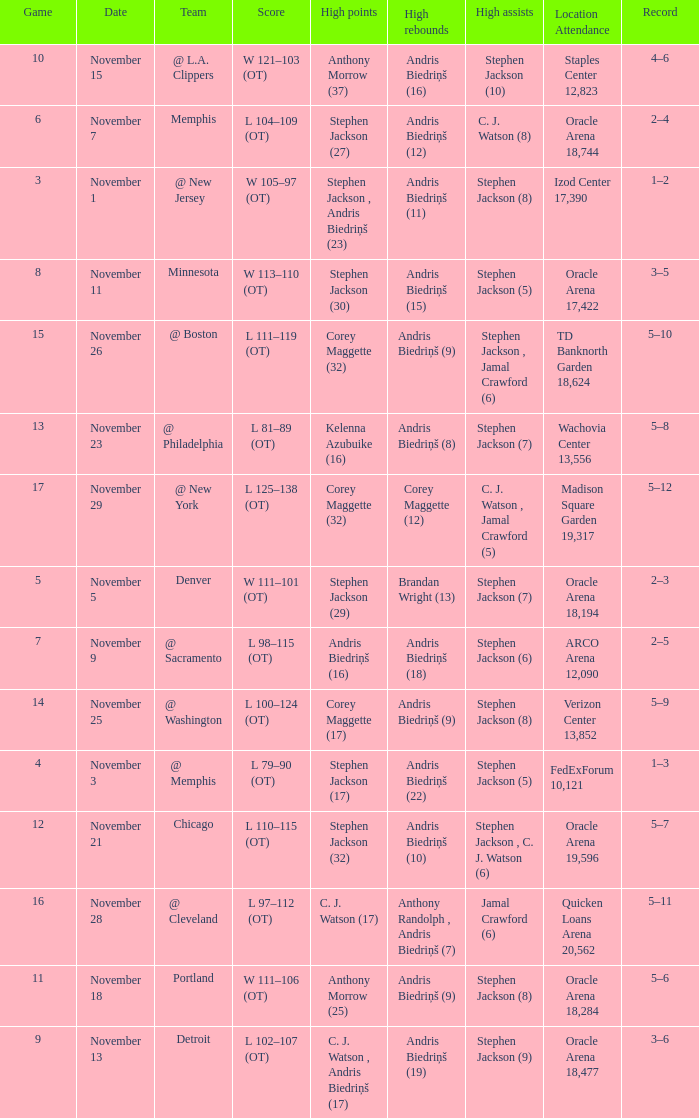What was the game number that was played on November 15? 10.0. Parse the full table. {'header': ['Game', 'Date', 'Team', 'Score', 'High points', 'High rebounds', 'High assists', 'Location Attendance', 'Record'], 'rows': [['10', 'November 15', '@ L.A. Clippers', 'W 121–103 (OT)', 'Anthony Morrow (37)', 'Andris Biedriņš (16)', 'Stephen Jackson (10)', 'Staples Center 12,823', '4–6'], ['6', 'November 7', 'Memphis', 'L 104–109 (OT)', 'Stephen Jackson (27)', 'Andris Biedriņš (12)', 'C. J. Watson (8)', 'Oracle Arena 18,744', '2–4'], ['3', 'November 1', '@ New Jersey', 'W 105–97 (OT)', 'Stephen Jackson , Andris Biedriņš (23)', 'Andris Biedriņš (11)', 'Stephen Jackson (8)', 'Izod Center 17,390', '1–2'], ['8', 'November 11', 'Minnesota', 'W 113–110 (OT)', 'Stephen Jackson (30)', 'Andris Biedriņš (15)', 'Stephen Jackson (5)', 'Oracle Arena 17,422', '3–5'], ['15', 'November 26', '@ Boston', 'L 111–119 (OT)', 'Corey Maggette (32)', 'Andris Biedriņš (9)', 'Stephen Jackson , Jamal Crawford (6)', 'TD Banknorth Garden 18,624', '5–10'], ['13', 'November 23', '@ Philadelphia', 'L 81–89 (OT)', 'Kelenna Azubuike (16)', 'Andris Biedriņš (8)', 'Stephen Jackson (7)', 'Wachovia Center 13,556', '5–8'], ['17', 'November 29', '@ New York', 'L 125–138 (OT)', 'Corey Maggette (32)', 'Corey Maggette (12)', 'C. J. Watson , Jamal Crawford (5)', 'Madison Square Garden 19,317', '5–12'], ['5', 'November 5', 'Denver', 'W 111–101 (OT)', 'Stephen Jackson (29)', 'Brandan Wright (13)', 'Stephen Jackson (7)', 'Oracle Arena 18,194', '2–3'], ['7', 'November 9', '@ Sacramento', 'L 98–115 (OT)', 'Andris Biedriņš (16)', 'Andris Biedriņš (18)', 'Stephen Jackson (6)', 'ARCO Arena 12,090', '2–5'], ['14', 'November 25', '@ Washington', 'L 100–124 (OT)', 'Corey Maggette (17)', 'Andris Biedriņš (9)', 'Stephen Jackson (8)', 'Verizon Center 13,852', '5–9'], ['4', 'November 3', '@ Memphis', 'L 79–90 (OT)', 'Stephen Jackson (17)', 'Andris Biedriņš (22)', 'Stephen Jackson (5)', 'FedExForum 10,121', '1–3'], ['12', 'November 21', 'Chicago', 'L 110–115 (OT)', 'Stephen Jackson (32)', 'Andris Biedriņš (10)', 'Stephen Jackson , C. J. Watson (6)', 'Oracle Arena 19,596', '5–7'], ['16', 'November 28', '@ Cleveland', 'L 97–112 (OT)', 'C. J. Watson (17)', 'Anthony Randolph , Andris Biedriņš (7)', 'Jamal Crawford (6)', 'Quicken Loans Arena 20,562', '5–11'], ['11', 'November 18', 'Portland', 'W 111–106 (OT)', 'Anthony Morrow (25)', 'Andris Biedriņš (9)', 'Stephen Jackson (8)', 'Oracle Arena 18,284', '5–6'], ['9', 'November 13', 'Detroit', 'L 102–107 (OT)', 'C. J. Watson , Andris Biedriņš (17)', 'Andris Biedriņš (19)', 'Stephen Jackson (9)', 'Oracle Arena 18,477', '3–6']]} 